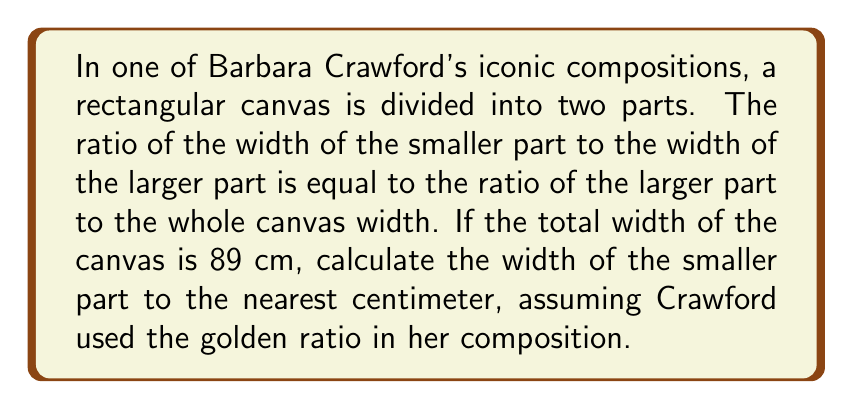Could you help me with this problem? Let's approach this step-by-step:

1) The golden ratio, often denoted by φ (phi), is approximately equal to 1.618033988749895.

2) Let x be the width of the smaller part and y be the width of the larger part. The total width is 89 cm.

3) According to the golden ratio principle:

   $$\frac{x}{y} = \frac{y}{x+y} = \frac{1}{\phi}$$

4) We know that x + y = 89 cm. Let's express y in terms of x:

   $$y = 89 - x$$

5) Substituting this into the golden ratio equation:

   $$\frac{x}{89-x} = \frac{1}{\phi}$$

6) Cross-multiplying:

   $$x\phi = 89 - x$$

7) Solving for x:

   $$x\phi + x = 89$$
   $$x(\phi + 1) = 89$$
   $$x = \frac{89}{\phi + 1}$$

8) We know that φ + 1 = φ^2 (a property of the golden ratio). So:

   $$x = \frac{89}{\phi^2}$$

9) Substituting the value of φ:

   $$x = \frac{89}{(1.618033988749895)^2} \approx 33.98 \text{ cm}$$

10) Rounding to the nearest centimeter:

    x ≈ 34 cm
Answer: 34 cm 